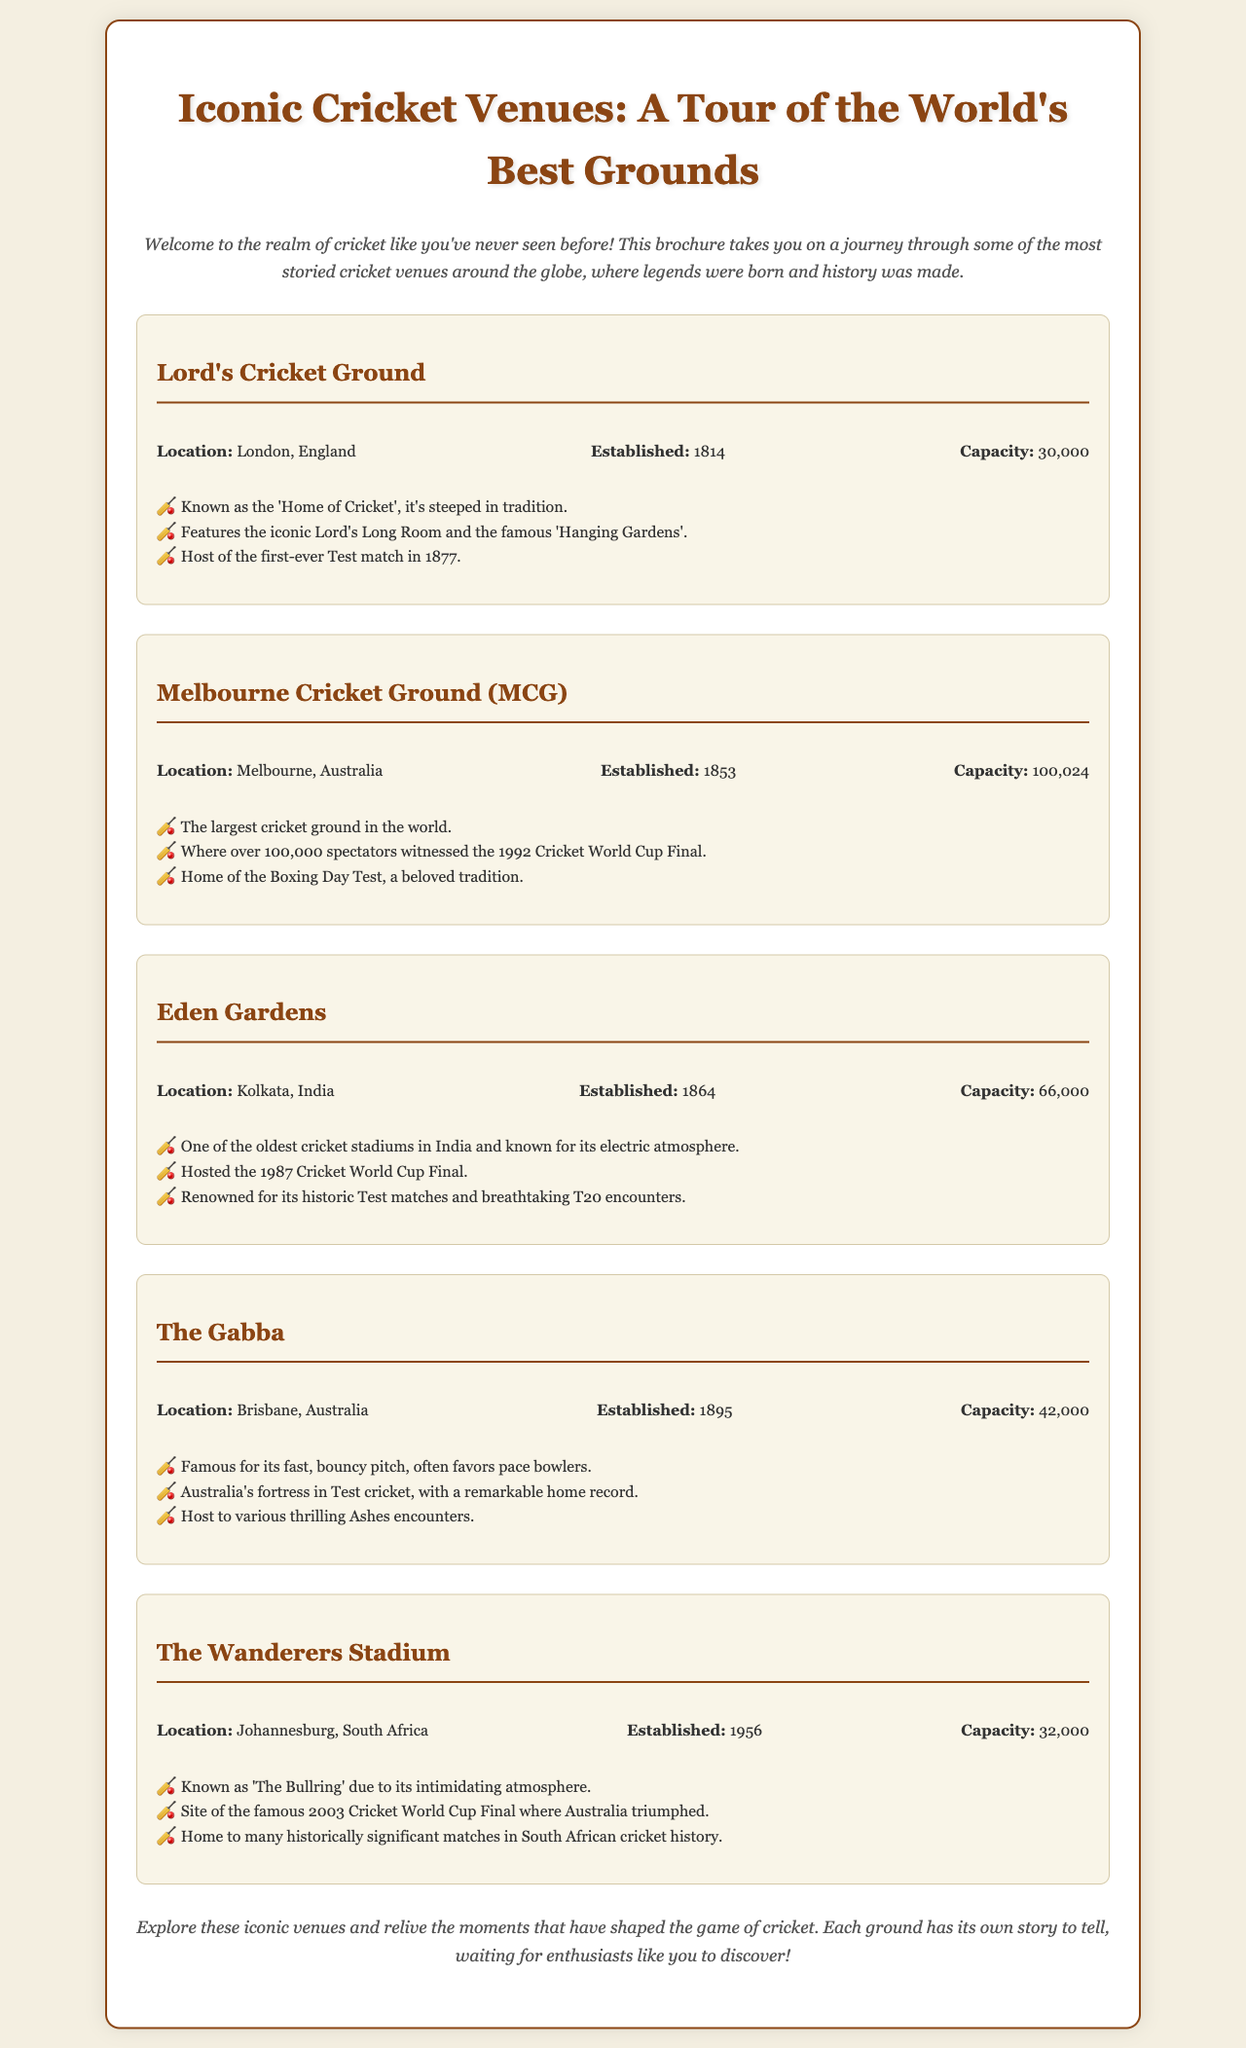What is the capacity of the Melbourne Cricket Ground? The capacity is listed in the document under Melbourne Cricket Ground's details, which states it can hold 100,024 spectators.
Answer: 100,024 When was Lord's Cricket Ground established? The establishment year for Lord's Cricket Ground is provided in the venue details, which mentions 1814.
Answer: 1814 Which venue is known as 'The Bullring'? The document mentions that The Wanderers Stadium is known as 'The Bullring.'
Answer: The Wanderers Stadium What significant event took place at Eden Gardens in 1987? The document notes that Eden Gardens hosted the 1987 Cricket World Cup Final.
Answer: 1987 Cricket World Cup Final Which cricket ground is referred to as the 'Home of Cricket'? The information states that Lord's Cricket Ground is referred to as the 'Home of Cricket.'
Answer: Lord's Cricket Ground What year was The Gabba established? The establishment year is found in the details of The Gabba, which was established in 1895.
Answer: 1895 Which venue has the largest capacity? The document indicates that the Melbourne Cricket Ground has the largest capacity among the listed venues.
Answer: Melbourne Cricket Ground What is a notable feature of the MCG? The document mentions that the MCG is where over 100,000 spectators witnessed the 1992 Cricket World Cup Final as a notable feature.
Answer: 1992 Cricket World Cup Final 